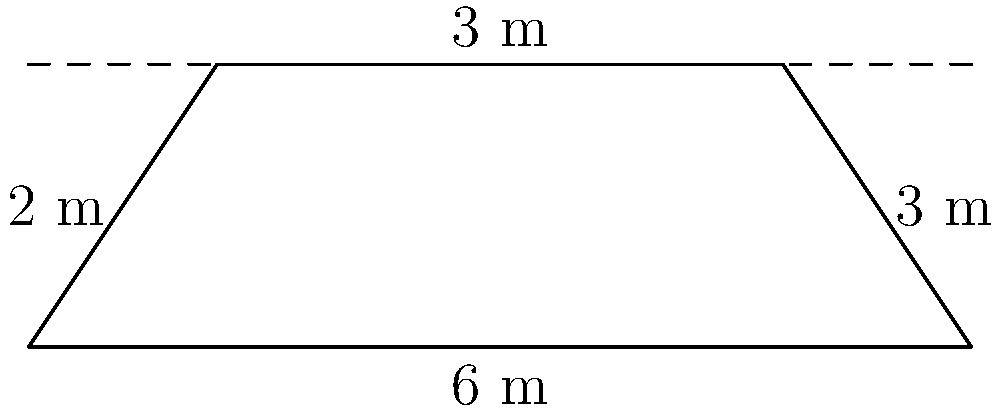A trapezoidal canal has a bottom width of 6 m, a depth of 3 m, and side slopes of 2:3 (horizontal:vertical) on the left side and 3:3 on the right side. Calculate the cross-sectional area of the canal. To calculate the cross-sectional area of the trapezoidal canal, we'll use the trapezoidal area formula and follow these steps:

1) The trapezoidal area formula is:
   $$A = \frac{1}{2}(b_1 + b_2)h$$
   where $A$ is the area, $b_1$ is the bottom width, $b_2$ is the top width, and $h$ is the height.

2) We know $b_1 = 6$ m and $h = 3$ m. We need to find $b_2$.

3) For the left side:
   Horizontal distance = $2 \times 3 = 6$ m (since the slope is 2:3)

4) For the right side:
   Horizontal distance = $3 \times 3 = 9$ m (since the slope is 3:3)

5) Therefore, $b_2 = 6 + 6 + 9 = 21$ m

6) Now we can apply the formula:
   $$A = \frac{1}{2}(6 + 21) \times 3$$
   $$A = \frac{1}{2} \times 27 \times 3$$
   $$A = 40.5 \text{ m}^2$$

Thus, the cross-sectional area of the canal is 40.5 square meters.
Answer: 40.5 m² 